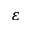<formula> <loc_0><loc_0><loc_500><loc_500>\varepsilon</formula> 